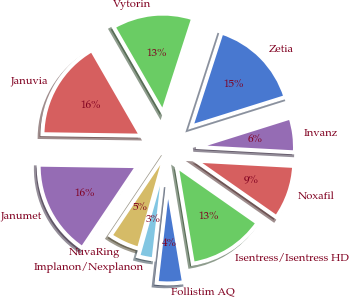Convert chart to OTSL. <chart><loc_0><loc_0><loc_500><loc_500><pie_chart><fcel>Zetia<fcel>Vytorin<fcel>Januvia<fcel>Janumet<fcel>NuvaRing<fcel>Implanon/Nexplanon<fcel>Follistim AQ<fcel>Isentress/Isentress HD<fcel>Noxafil<fcel>Invanz<nl><fcel>15.19%<fcel>13.29%<fcel>16.45%<fcel>15.82%<fcel>5.07%<fcel>2.54%<fcel>4.43%<fcel>12.66%<fcel>8.86%<fcel>5.7%<nl></chart> 